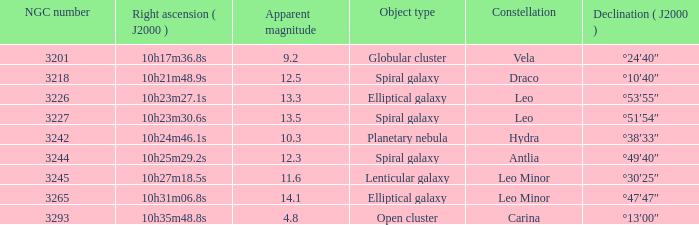Help me parse the entirety of this table. {'header': ['NGC number', 'Right ascension ( J2000 )', 'Apparent magnitude', 'Object type', 'Constellation', 'Declination ( J2000 )'], 'rows': [['3201', '10h17m36.8s', '9.2', 'Globular cluster', 'Vela', '°24′40″'], ['3218', '10h21m48.9s', '12.5', 'Spiral galaxy', 'Draco', '°10′40″'], ['3226', '10h23m27.1s', '13.3', 'Elliptical galaxy', 'Leo', '°53′55″'], ['3227', '10h23m30.6s', '13.5', 'Spiral galaxy', 'Leo', '°51′54″'], ['3242', '10h24m46.1s', '10.3', 'Planetary nebula', 'Hydra', '°38′33″'], ['3244', '10h25m29.2s', '12.3', 'Spiral galaxy', 'Antlia', '°49′40″'], ['3245', '10h27m18.5s', '11.6', 'Lenticular galaxy', 'Leo Minor', '°30′25″'], ['3265', '10h31m06.8s', '14.1', 'Elliptical galaxy', 'Leo Minor', '°47′47″'], ['3293', '10h35m48.8s', '4.8', 'Open cluster', 'Carina', '°13′00″']]} What is the sum of NGC numbers for Constellation vela? 3201.0. 